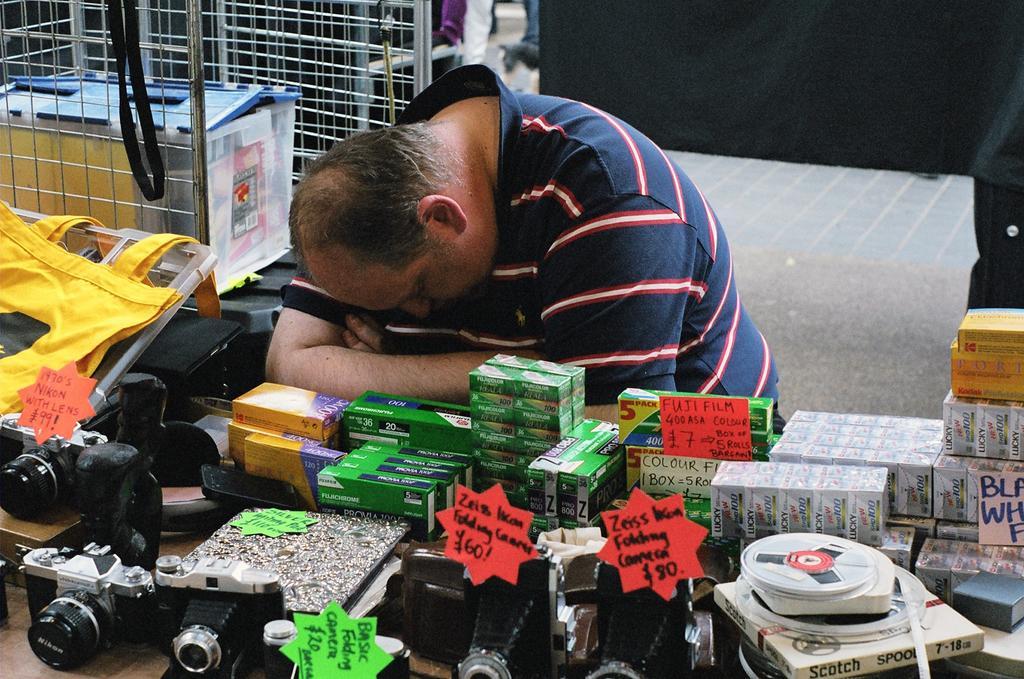Could you give a brief overview of what you see in this image? In this image we can see cameras and other objects on the table. There is a person sleeping. In the background of the image there is a black colored cloth. There is a grill with some object in it. 